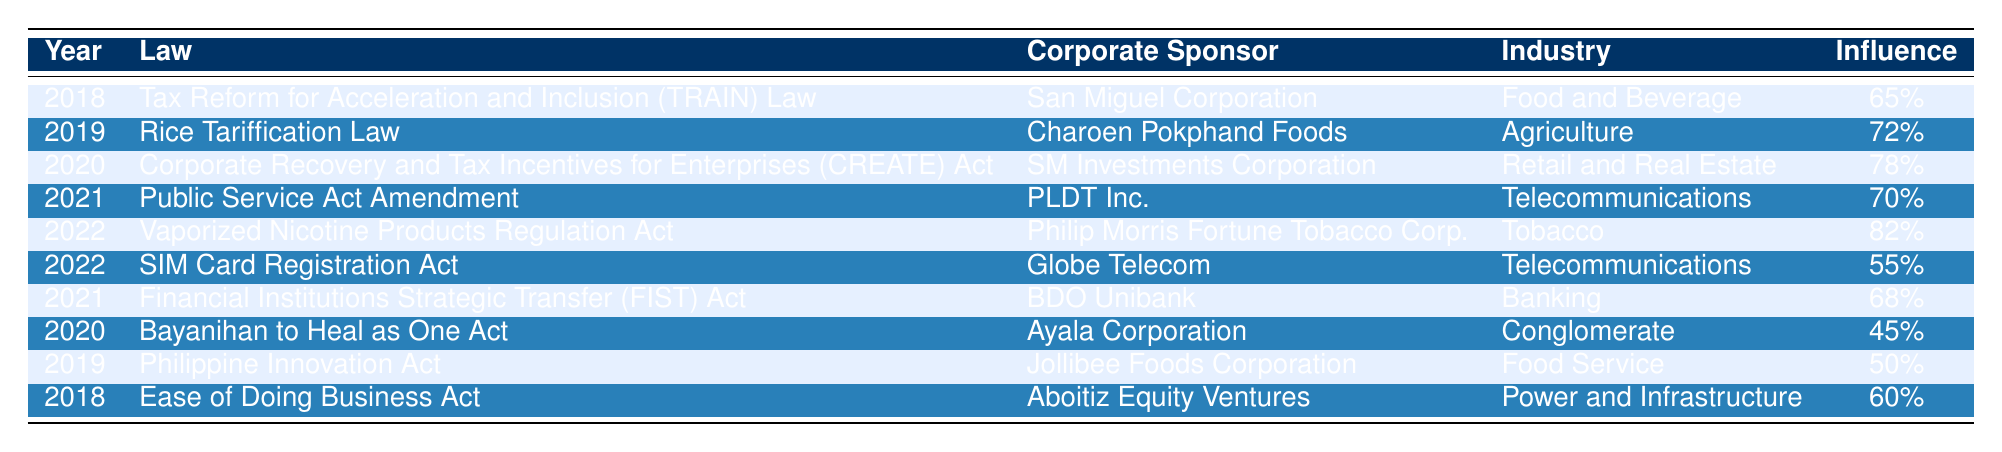What is the law with the highest percentage of corporate influence? The table shows that the Vaporized Nicotine Products Regulation Act has the highest percentage of corporate influence at 82%.
Answer: Vaporized Nicotine Products Regulation Act How many laws had a percentage of corporate influence greater than 70%? By examining the table, the following laws had more than 70% influence: Rice Tariffication Law (72%), CREATE Act (78%), Public Service Act Amendment (70%), and Vaporized Nicotine Products Regulation Act (82%). This totals 4 laws.
Answer: 4 What is the average percentage of influence for all the laws listed? To find the average, we first sum the percentages of influence: 65 + 72 + 78 + 70 + 82 + 55 + 68 + 45 + 50 + 60 = 710. Since there are 10 laws, we divide 710 by 10, which gives us an average of 71%.
Answer: 71% Is the corporate influence on the SIM Card Registration Act higher than that of the Tax Reform for Acceleration and Inclusion Law? The SIM Card Registration Act has a 55% influence while the Tax Reform for Acceleration and Inclusion Law has a 65% influence. Since 55% is less than 65%, the statement is false.
Answer: No What percentage difference in corporate influence exists between the law sponsored by San Miguel Corporation and the law sponsored by Philip Morris Fortune Tobacco Corp.? The influence for the Tax Reform for Acceleration and Inclusion Law (San Miguel Corporation) is 65%, and for the Vaporized Nicotine Products Regulation Act (Philip Morris) is 82%. The difference is 82% - 65% = 17%.
Answer: 17% Which industry had the most laws with significant corporate influence, considering a threshold of 70%? Focusing on the laws with 70% or greater influence, we have Agriculture, Retail and Real Estate, Telecommunications, and Tobacco. The Tobacco industry appears once in this list, but Agriculture and Retail appear only once as well, meaning there's no dominating industry in terms of quantity.
Answer: None What was the lowest percentage of corporate influence among the listed laws? The lowest percentage of corporate influence found in the table is 45% from the Bayanihan to Heal as One Act.
Answer: 45% Did the years 2021 and 2022 show an increase in corporate influence on laws compared to 2018? In 2018, the highest influence was 65%, while in 2021 and 2022, we have influences of 70%, 68%, and 82% respectively. Hence, the influence increased over those years compared to 2018.
Answer: Yes How many laws were passed in 2021 and what was their average influence? In 2021, there were 2 laws: Public Service Act Amendment (70%) and FIST Act (68%). Adding these gives 138%, and dividing by 2 results in an average of 69%.
Answer: 69% What percentage of laws mentioned were sponsored by telecommunications companies? The table shows that there are 3 laws sponsored by telecommunications companies (Public Service Act Amendment, SIM Card Registration Act, and one from PLDT). Their percentage total is 70% + 55% + 70% = 195%. Dividing by 3 gives 65%.
Answer: 65% 